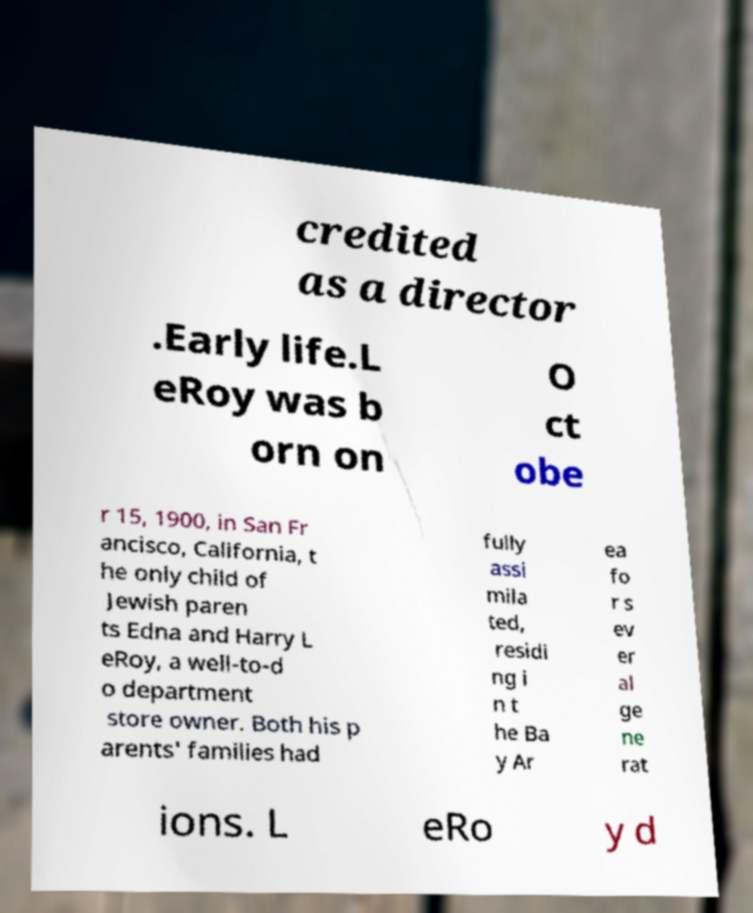I need the written content from this picture converted into text. Can you do that? credited as a director .Early life.L eRoy was b orn on O ct obe r 15, 1900, in San Fr ancisco, California, t he only child of Jewish paren ts Edna and Harry L eRoy, a well-to-d o department store owner. Both his p arents' families had fully assi mila ted, residi ng i n t he Ba y Ar ea fo r s ev er al ge ne rat ions. L eRo y d 